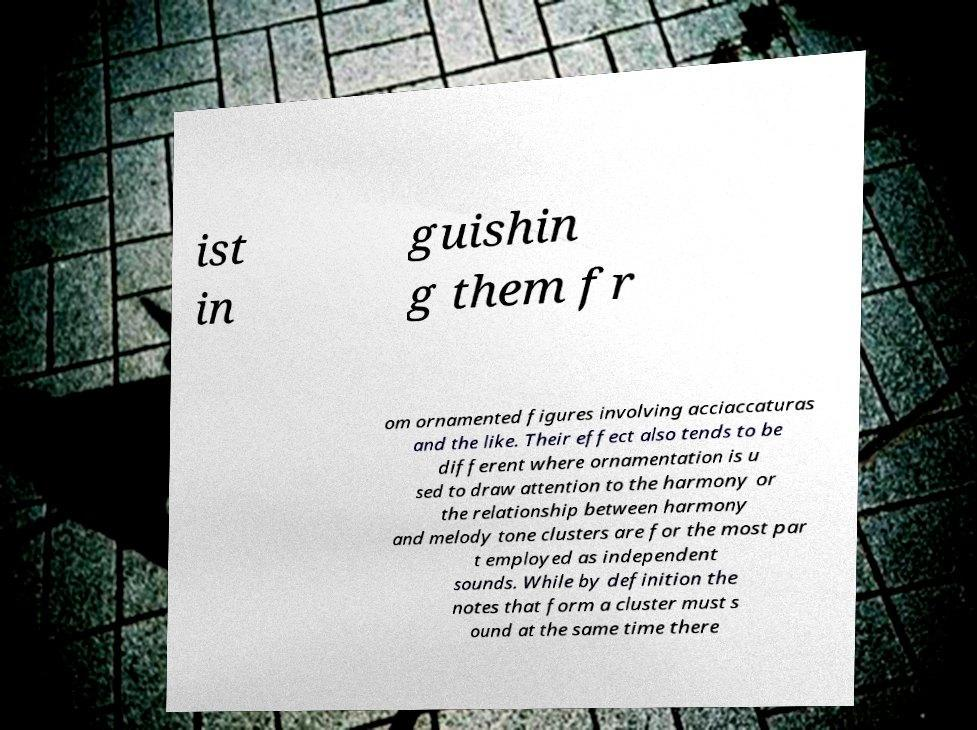Please read and relay the text visible in this image. What does it say? ist in guishin g them fr om ornamented figures involving acciaccaturas and the like. Their effect also tends to be different where ornamentation is u sed to draw attention to the harmony or the relationship between harmony and melody tone clusters are for the most par t employed as independent sounds. While by definition the notes that form a cluster must s ound at the same time there 